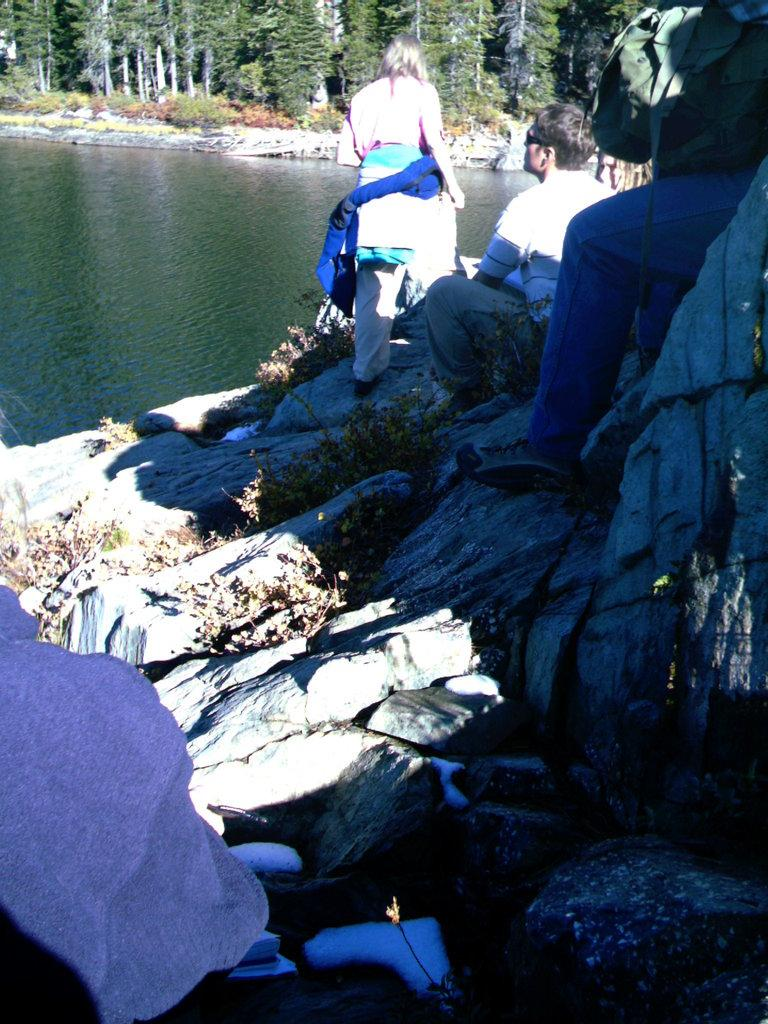What is the man in the image doing? The man is sitting on a rock in the image. How many people are in the image? There are people in the image, but the exact number is not specified. What can be seen in the background of the image? There is a lake and trees in the background of the image. What is present at the bottom of the image? There are stones at the bottom of the image. What type of hose is being used by the man in the image? There is no hose present in the image; the man is simply sitting on a rock. What is the man holding in his hand in the image? The provided facts do not mention any specific object that the man is holding in his hand. 